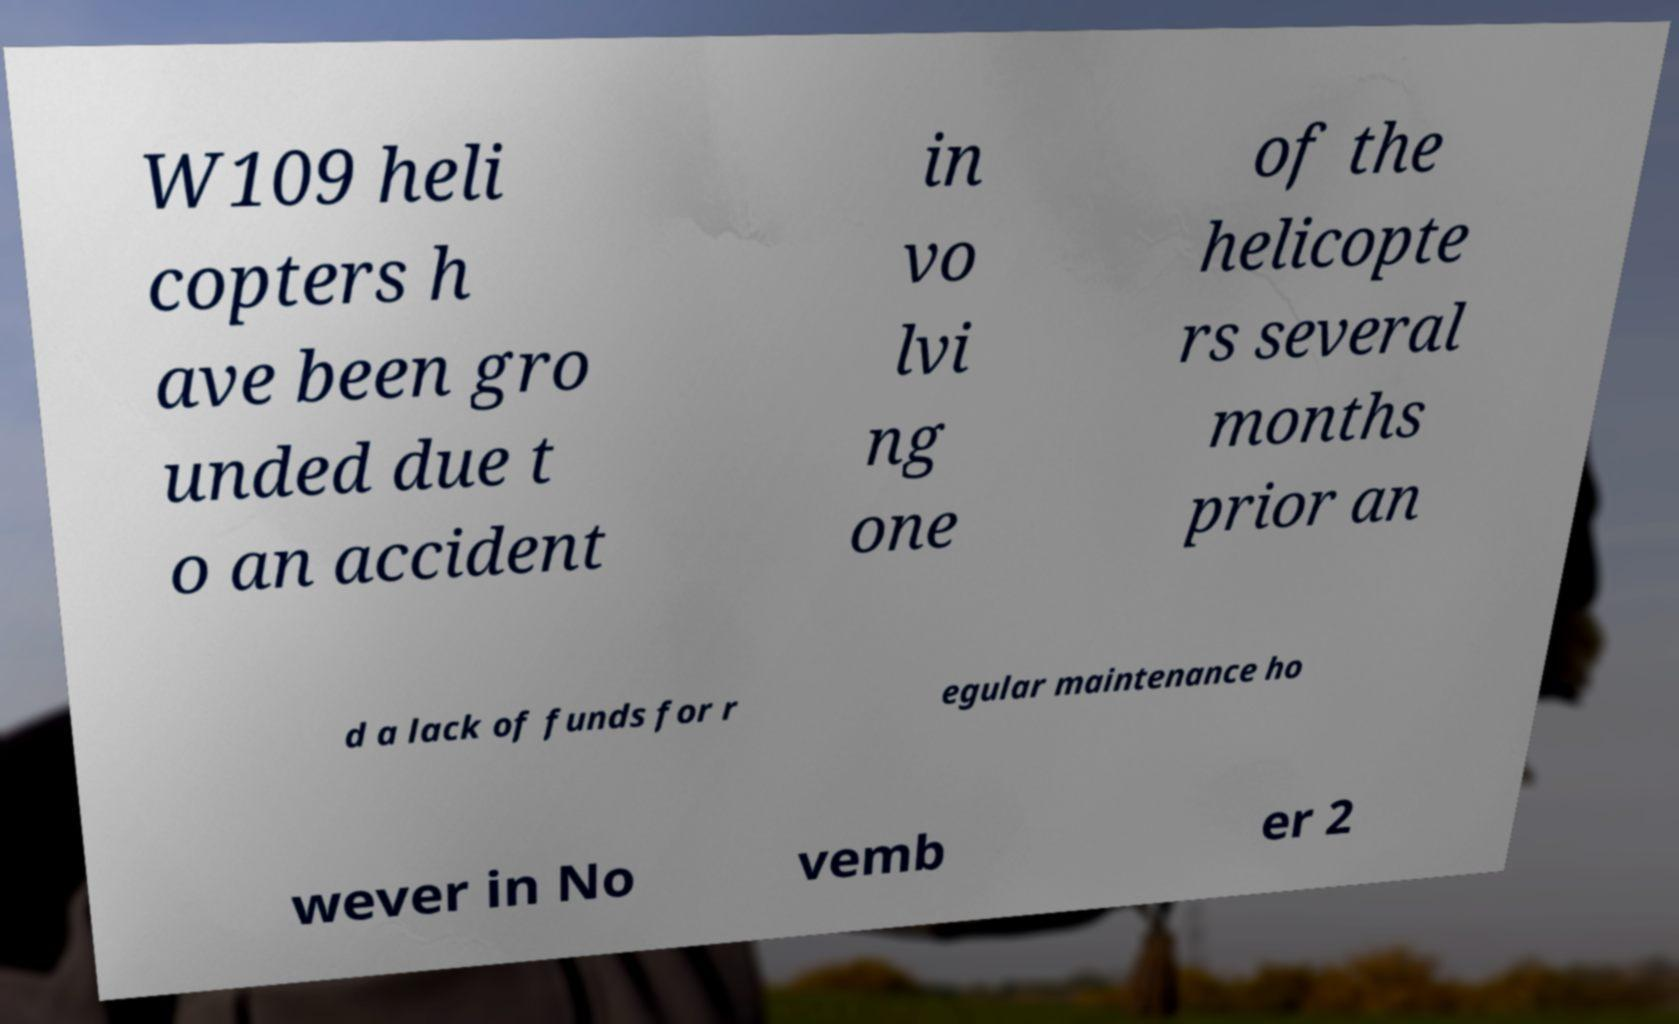For documentation purposes, I need the text within this image transcribed. Could you provide that? W109 heli copters h ave been gro unded due t o an accident in vo lvi ng one of the helicopte rs several months prior an d a lack of funds for r egular maintenance ho wever in No vemb er 2 